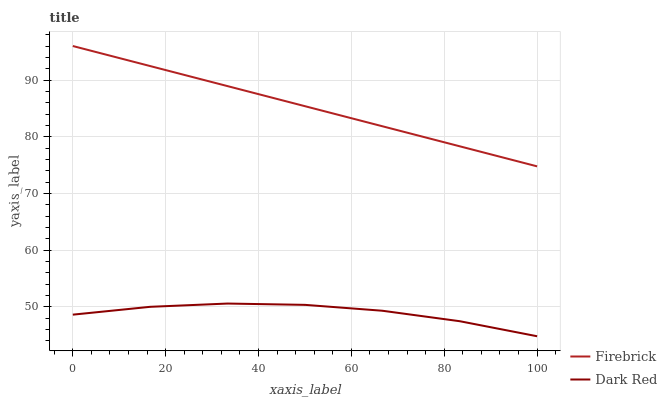Does Dark Red have the minimum area under the curve?
Answer yes or no. Yes. Does Firebrick have the maximum area under the curve?
Answer yes or no. Yes. Does Firebrick have the minimum area under the curve?
Answer yes or no. No. Is Firebrick the smoothest?
Answer yes or no. Yes. Is Dark Red the roughest?
Answer yes or no. Yes. Is Firebrick the roughest?
Answer yes or no. No. Does Dark Red have the lowest value?
Answer yes or no. Yes. Does Firebrick have the lowest value?
Answer yes or no. No. Does Firebrick have the highest value?
Answer yes or no. Yes. Is Dark Red less than Firebrick?
Answer yes or no. Yes. Is Firebrick greater than Dark Red?
Answer yes or no. Yes. Does Dark Red intersect Firebrick?
Answer yes or no. No. 